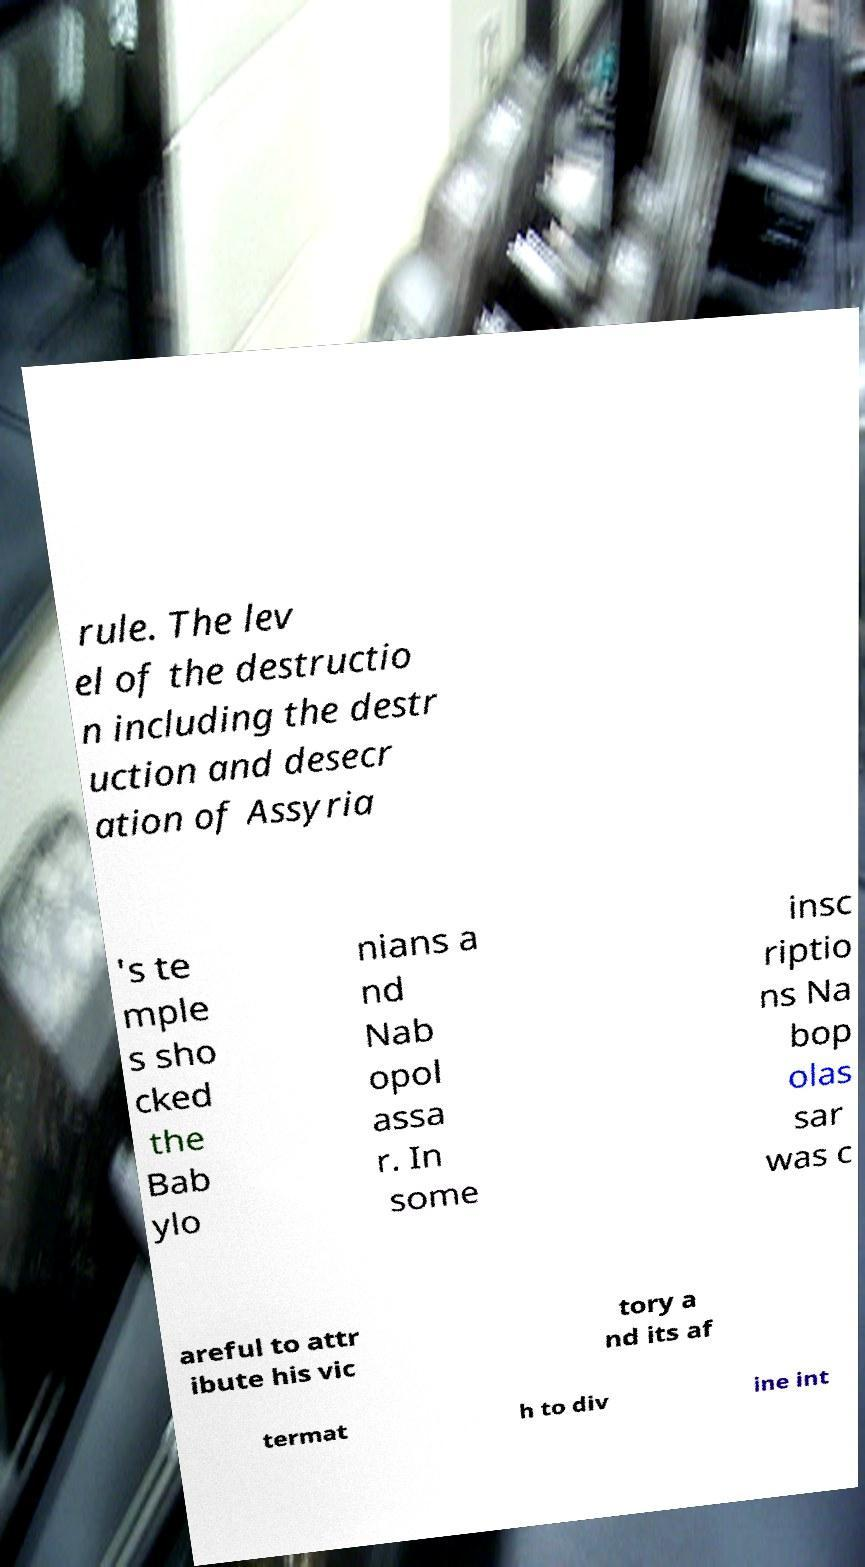Please identify and transcribe the text found in this image. rule. The lev el of the destructio n including the destr uction and desecr ation of Assyria 's te mple s sho cked the Bab ylo nians a nd Nab opol assa r. In some insc riptio ns Na bop olas sar was c areful to attr ibute his vic tory a nd its af termat h to div ine int 